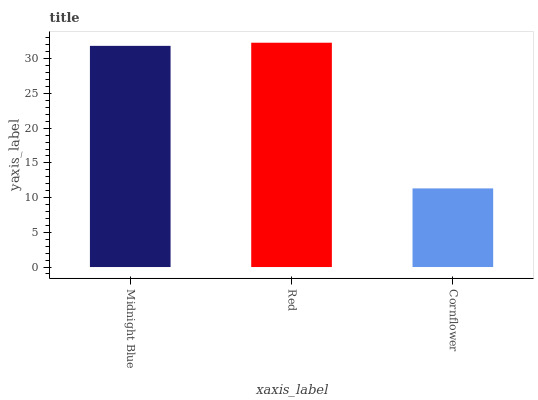Is Cornflower the minimum?
Answer yes or no. Yes. Is Red the maximum?
Answer yes or no. Yes. Is Red the minimum?
Answer yes or no. No. Is Cornflower the maximum?
Answer yes or no. No. Is Red greater than Cornflower?
Answer yes or no. Yes. Is Cornflower less than Red?
Answer yes or no. Yes. Is Cornflower greater than Red?
Answer yes or no. No. Is Red less than Cornflower?
Answer yes or no. No. Is Midnight Blue the high median?
Answer yes or no. Yes. Is Midnight Blue the low median?
Answer yes or no. Yes. Is Red the high median?
Answer yes or no. No. Is Red the low median?
Answer yes or no. No. 